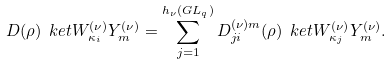Convert formula to latex. <formula><loc_0><loc_0><loc_500><loc_500>D ( \rho ) \ k e t { W _ { \kappa _ { i } } ^ { ( \nu ) } Y _ { m } ^ { ( \nu ) } } = \sum _ { j = 1 } ^ { h _ { \nu } ( G L _ { q } ) } D ^ { ( \nu ) m } _ { j i } ( \rho ) \ k e t { W _ { \kappa _ { j } } ^ { ( \nu ) } Y _ { m } ^ { ( \nu ) } } .</formula> 